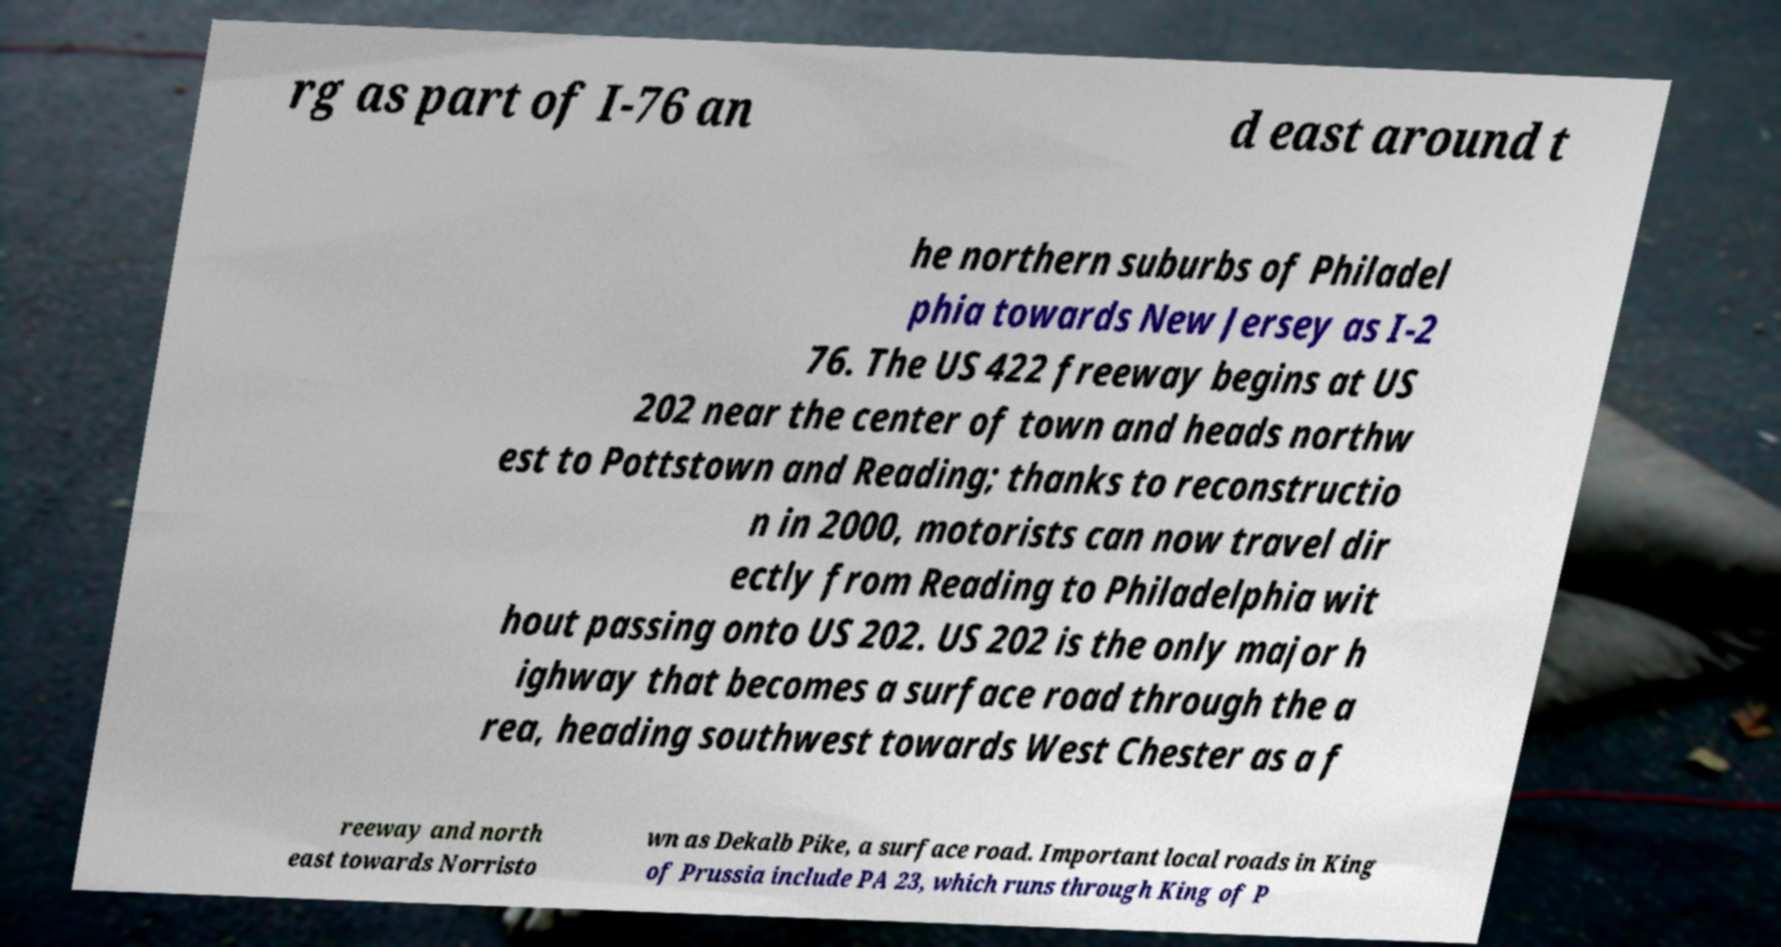I need the written content from this picture converted into text. Can you do that? rg as part of I-76 an d east around t he northern suburbs of Philadel phia towards New Jersey as I-2 76. The US 422 freeway begins at US 202 near the center of town and heads northw est to Pottstown and Reading; thanks to reconstructio n in 2000, motorists can now travel dir ectly from Reading to Philadelphia wit hout passing onto US 202. US 202 is the only major h ighway that becomes a surface road through the a rea, heading southwest towards West Chester as a f reeway and north east towards Norristo wn as Dekalb Pike, a surface road. Important local roads in King of Prussia include PA 23, which runs through King of P 